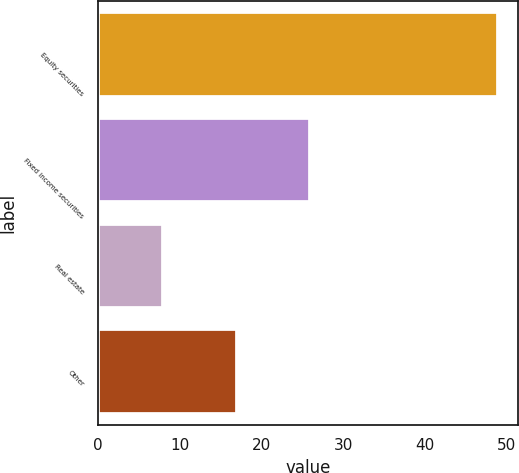Convert chart to OTSL. <chart><loc_0><loc_0><loc_500><loc_500><bar_chart><fcel>Equity securities<fcel>Fixed income securities<fcel>Real estate<fcel>Other<nl><fcel>49<fcel>26<fcel>8<fcel>17<nl></chart> 